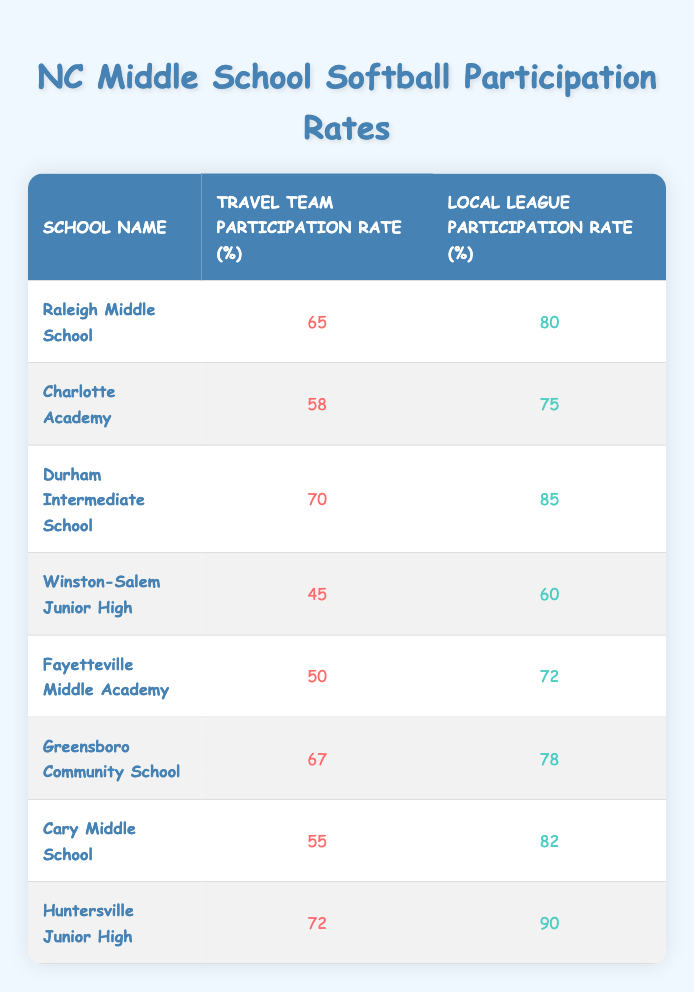What is the travel team participation rate for Raleigh Middle School? The table lists the travel team participation rate for Raleigh Middle School as 65%. This information is found directly in the row corresponding to Raleigh Middle School.
Answer: 65% What is the local league participation rate for Winston-Salem Junior High? According to the table, the local league participation rate for Winston-Salem Junior High is 60%. This is stated directly in the relevant row of the table.
Answer: 60% Which school has the highest local league participation rate? The table shows that Huntersville Junior High has the highest local league participation rate of 90%. By reviewing all the rates listed, it's clear that this value is the highest.
Answer: 90% Calculate the average travel team participation rate among the listed schools. To find the average travel team participation rate, first sum the travel rates: 65 + 58 + 70 + 45 + 50 + 67 + 55 + 72 = 482. Then, divide this by the number of schools, which is 8. So, 482 / 8 = 60.25.
Answer: 60.25 Is it true that all schools have a local league participation rate above 70%? By examining the table, we see that Winston-Salem Junior High has a local league participation rate of 60%, which is not above 70%. Therefore, the statement is false.
Answer: No What is the difference between the highest and lowest travel team participation rates? The highest travel team participation rate is 72% (from Huntersville Junior High) and the lowest is 45% (from Winston-Salem Junior High). The difference is calculated as 72 - 45 = 27.
Answer: 27 Which school has the lowest travel team participation rate? According to the table, the school with the lowest travel team participation rate is Winston-Salem Junior High, with a rate of 45%. This is directly stated in the relevant row of the table.
Answer: Winston-Salem Junior High How many schools have a local league participation rate of 75% or higher? Reviewing the table, the schools with local league participation rates of 75% or higher are: Raleigh Middle School (80%), Durham Intermediate School (85%), Greensboro Community School (78%), Cary Middle School (82%), and Huntersville Junior High (90%). This gives us a total of 5 schools.
Answer: 5 